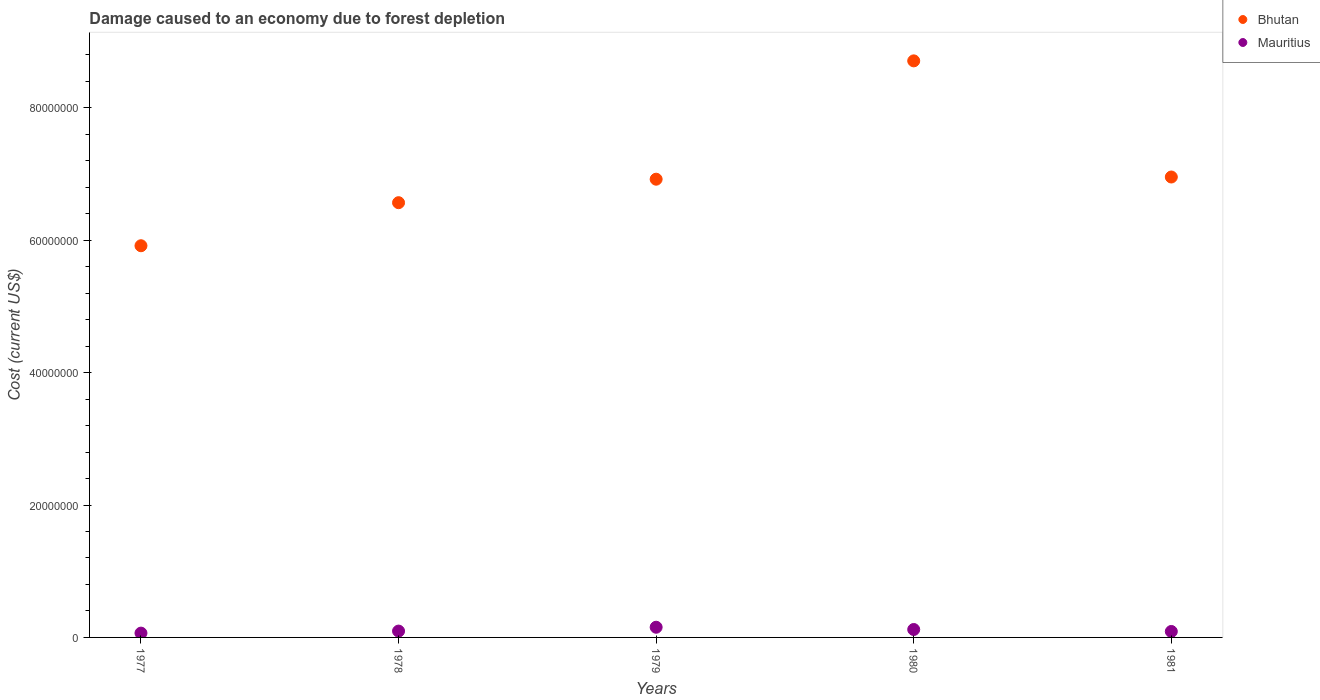Is the number of dotlines equal to the number of legend labels?
Provide a succinct answer. Yes. What is the cost of damage caused due to forest depletion in Bhutan in 1979?
Your answer should be very brief. 6.92e+07. Across all years, what is the maximum cost of damage caused due to forest depletion in Mauritius?
Keep it short and to the point. 1.54e+06. Across all years, what is the minimum cost of damage caused due to forest depletion in Mauritius?
Offer a terse response. 6.50e+05. In which year was the cost of damage caused due to forest depletion in Mauritius maximum?
Provide a short and direct response. 1979. What is the total cost of damage caused due to forest depletion in Bhutan in the graph?
Your response must be concise. 3.51e+08. What is the difference between the cost of damage caused due to forest depletion in Bhutan in 1980 and that in 1981?
Give a very brief answer. 1.75e+07. What is the difference between the cost of damage caused due to forest depletion in Bhutan in 1981 and the cost of damage caused due to forest depletion in Mauritius in 1980?
Your answer should be compact. 6.83e+07. What is the average cost of damage caused due to forest depletion in Bhutan per year?
Your response must be concise. 7.01e+07. In the year 1977, what is the difference between the cost of damage caused due to forest depletion in Bhutan and cost of damage caused due to forest depletion in Mauritius?
Provide a succinct answer. 5.85e+07. What is the ratio of the cost of damage caused due to forest depletion in Mauritius in 1979 to that in 1981?
Ensure brevity in your answer.  1.71. What is the difference between the highest and the second highest cost of damage caused due to forest depletion in Mauritius?
Provide a short and direct response. 3.41e+05. What is the difference between the highest and the lowest cost of damage caused due to forest depletion in Bhutan?
Give a very brief answer. 2.79e+07. Does the cost of damage caused due to forest depletion in Bhutan monotonically increase over the years?
Provide a succinct answer. No. Is the cost of damage caused due to forest depletion in Bhutan strictly greater than the cost of damage caused due to forest depletion in Mauritius over the years?
Ensure brevity in your answer.  Yes. How many dotlines are there?
Keep it short and to the point. 2. How many years are there in the graph?
Your response must be concise. 5. What is the difference between two consecutive major ticks on the Y-axis?
Your answer should be very brief. 2.00e+07. How many legend labels are there?
Give a very brief answer. 2. What is the title of the graph?
Make the answer very short. Damage caused to an economy due to forest depletion. Does "Bahamas" appear as one of the legend labels in the graph?
Your answer should be very brief. No. What is the label or title of the X-axis?
Keep it short and to the point. Years. What is the label or title of the Y-axis?
Offer a very short reply. Cost (current US$). What is the Cost (current US$) in Bhutan in 1977?
Your answer should be very brief. 5.92e+07. What is the Cost (current US$) in Mauritius in 1977?
Your answer should be compact. 6.50e+05. What is the Cost (current US$) of Bhutan in 1978?
Your answer should be very brief. 6.57e+07. What is the Cost (current US$) of Mauritius in 1978?
Offer a terse response. 9.57e+05. What is the Cost (current US$) in Bhutan in 1979?
Provide a succinct answer. 6.92e+07. What is the Cost (current US$) in Mauritius in 1979?
Make the answer very short. 1.54e+06. What is the Cost (current US$) of Bhutan in 1980?
Your answer should be very brief. 8.71e+07. What is the Cost (current US$) of Mauritius in 1980?
Ensure brevity in your answer.  1.20e+06. What is the Cost (current US$) of Bhutan in 1981?
Make the answer very short. 6.95e+07. What is the Cost (current US$) in Mauritius in 1981?
Your answer should be compact. 8.99e+05. Across all years, what is the maximum Cost (current US$) in Bhutan?
Give a very brief answer. 8.71e+07. Across all years, what is the maximum Cost (current US$) of Mauritius?
Make the answer very short. 1.54e+06. Across all years, what is the minimum Cost (current US$) in Bhutan?
Your answer should be very brief. 5.92e+07. Across all years, what is the minimum Cost (current US$) of Mauritius?
Your answer should be very brief. 6.50e+05. What is the total Cost (current US$) in Bhutan in the graph?
Offer a terse response. 3.51e+08. What is the total Cost (current US$) in Mauritius in the graph?
Provide a short and direct response. 5.24e+06. What is the difference between the Cost (current US$) of Bhutan in 1977 and that in 1978?
Your response must be concise. -6.50e+06. What is the difference between the Cost (current US$) of Mauritius in 1977 and that in 1978?
Give a very brief answer. -3.07e+05. What is the difference between the Cost (current US$) in Bhutan in 1977 and that in 1979?
Offer a terse response. -1.00e+07. What is the difference between the Cost (current US$) of Mauritius in 1977 and that in 1979?
Provide a succinct answer. -8.88e+05. What is the difference between the Cost (current US$) in Bhutan in 1977 and that in 1980?
Offer a very short reply. -2.79e+07. What is the difference between the Cost (current US$) in Mauritius in 1977 and that in 1980?
Offer a very short reply. -5.47e+05. What is the difference between the Cost (current US$) of Bhutan in 1977 and that in 1981?
Give a very brief answer. -1.04e+07. What is the difference between the Cost (current US$) in Mauritius in 1977 and that in 1981?
Ensure brevity in your answer.  -2.49e+05. What is the difference between the Cost (current US$) of Bhutan in 1978 and that in 1979?
Offer a very short reply. -3.55e+06. What is the difference between the Cost (current US$) of Mauritius in 1978 and that in 1979?
Offer a very short reply. -5.82e+05. What is the difference between the Cost (current US$) in Bhutan in 1978 and that in 1980?
Give a very brief answer. -2.14e+07. What is the difference between the Cost (current US$) of Mauritius in 1978 and that in 1980?
Offer a terse response. -2.40e+05. What is the difference between the Cost (current US$) of Bhutan in 1978 and that in 1981?
Your answer should be very brief. -3.88e+06. What is the difference between the Cost (current US$) of Mauritius in 1978 and that in 1981?
Your answer should be compact. 5.78e+04. What is the difference between the Cost (current US$) of Bhutan in 1979 and that in 1980?
Offer a very short reply. -1.79e+07. What is the difference between the Cost (current US$) in Mauritius in 1979 and that in 1980?
Provide a short and direct response. 3.41e+05. What is the difference between the Cost (current US$) of Bhutan in 1979 and that in 1981?
Give a very brief answer. -3.31e+05. What is the difference between the Cost (current US$) of Mauritius in 1979 and that in 1981?
Provide a succinct answer. 6.39e+05. What is the difference between the Cost (current US$) in Bhutan in 1980 and that in 1981?
Provide a short and direct response. 1.75e+07. What is the difference between the Cost (current US$) in Mauritius in 1980 and that in 1981?
Provide a succinct answer. 2.98e+05. What is the difference between the Cost (current US$) in Bhutan in 1977 and the Cost (current US$) in Mauritius in 1978?
Make the answer very short. 5.82e+07. What is the difference between the Cost (current US$) of Bhutan in 1977 and the Cost (current US$) of Mauritius in 1979?
Provide a succinct answer. 5.76e+07. What is the difference between the Cost (current US$) in Bhutan in 1977 and the Cost (current US$) in Mauritius in 1980?
Keep it short and to the point. 5.80e+07. What is the difference between the Cost (current US$) of Bhutan in 1977 and the Cost (current US$) of Mauritius in 1981?
Provide a succinct answer. 5.83e+07. What is the difference between the Cost (current US$) of Bhutan in 1978 and the Cost (current US$) of Mauritius in 1979?
Ensure brevity in your answer.  6.41e+07. What is the difference between the Cost (current US$) in Bhutan in 1978 and the Cost (current US$) in Mauritius in 1980?
Give a very brief answer. 6.45e+07. What is the difference between the Cost (current US$) of Bhutan in 1978 and the Cost (current US$) of Mauritius in 1981?
Offer a terse response. 6.48e+07. What is the difference between the Cost (current US$) in Bhutan in 1979 and the Cost (current US$) in Mauritius in 1980?
Your response must be concise. 6.80e+07. What is the difference between the Cost (current US$) of Bhutan in 1979 and the Cost (current US$) of Mauritius in 1981?
Your answer should be very brief. 6.83e+07. What is the difference between the Cost (current US$) in Bhutan in 1980 and the Cost (current US$) in Mauritius in 1981?
Give a very brief answer. 8.62e+07. What is the average Cost (current US$) of Bhutan per year?
Offer a terse response. 7.01e+07. What is the average Cost (current US$) in Mauritius per year?
Provide a succinct answer. 1.05e+06. In the year 1977, what is the difference between the Cost (current US$) in Bhutan and Cost (current US$) in Mauritius?
Make the answer very short. 5.85e+07. In the year 1978, what is the difference between the Cost (current US$) of Bhutan and Cost (current US$) of Mauritius?
Give a very brief answer. 6.47e+07. In the year 1979, what is the difference between the Cost (current US$) in Bhutan and Cost (current US$) in Mauritius?
Make the answer very short. 6.77e+07. In the year 1980, what is the difference between the Cost (current US$) in Bhutan and Cost (current US$) in Mauritius?
Provide a short and direct response. 8.59e+07. In the year 1981, what is the difference between the Cost (current US$) in Bhutan and Cost (current US$) in Mauritius?
Make the answer very short. 6.86e+07. What is the ratio of the Cost (current US$) of Bhutan in 1977 to that in 1978?
Your response must be concise. 0.9. What is the ratio of the Cost (current US$) in Mauritius in 1977 to that in 1978?
Your answer should be very brief. 0.68. What is the ratio of the Cost (current US$) of Bhutan in 1977 to that in 1979?
Keep it short and to the point. 0.85. What is the ratio of the Cost (current US$) in Mauritius in 1977 to that in 1979?
Keep it short and to the point. 0.42. What is the ratio of the Cost (current US$) in Bhutan in 1977 to that in 1980?
Make the answer very short. 0.68. What is the ratio of the Cost (current US$) of Mauritius in 1977 to that in 1980?
Ensure brevity in your answer.  0.54. What is the ratio of the Cost (current US$) in Bhutan in 1977 to that in 1981?
Your answer should be compact. 0.85. What is the ratio of the Cost (current US$) of Mauritius in 1977 to that in 1981?
Offer a terse response. 0.72. What is the ratio of the Cost (current US$) in Bhutan in 1978 to that in 1979?
Your answer should be compact. 0.95. What is the ratio of the Cost (current US$) in Mauritius in 1978 to that in 1979?
Make the answer very short. 0.62. What is the ratio of the Cost (current US$) in Bhutan in 1978 to that in 1980?
Keep it short and to the point. 0.75. What is the ratio of the Cost (current US$) of Mauritius in 1978 to that in 1980?
Make the answer very short. 0.8. What is the ratio of the Cost (current US$) of Bhutan in 1978 to that in 1981?
Offer a terse response. 0.94. What is the ratio of the Cost (current US$) of Mauritius in 1978 to that in 1981?
Your answer should be compact. 1.06. What is the ratio of the Cost (current US$) of Bhutan in 1979 to that in 1980?
Ensure brevity in your answer.  0.79. What is the ratio of the Cost (current US$) in Mauritius in 1979 to that in 1980?
Your response must be concise. 1.29. What is the ratio of the Cost (current US$) in Bhutan in 1979 to that in 1981?
Give a very brief answer. 1. What is the ratio of the Cost (current US$) in Mauritius in 1979 to that in 1981?
Provide a succinct answer. 1.71. What is the ratio of the Cost (current US$) of Bhutan in 1980 to that in 1981?
Keep it short and to the point. 1.25. What is the ratio of the Cost (current US$) of Mauritius in 1980 to that in 1981?
Keep it short and to the point. 1.33. What is the difference between the highest and the second highest Cost (current US$) in Bhutan?
Your answer should be compact. 1.75e+07. What is the difference between the highest and the second highest Cost (current US$) of Mauritius?
Your answer should be very brief. 3.41e+05. What is the difference between the highest and the lowest Cost (current US$) in Bhutan?
Your response must be concise. 2.79e+07. What is the difference between the highest and the lowest Cost (current US$) in Mauritius?
Offer a very short reply. 8.88e+05. 